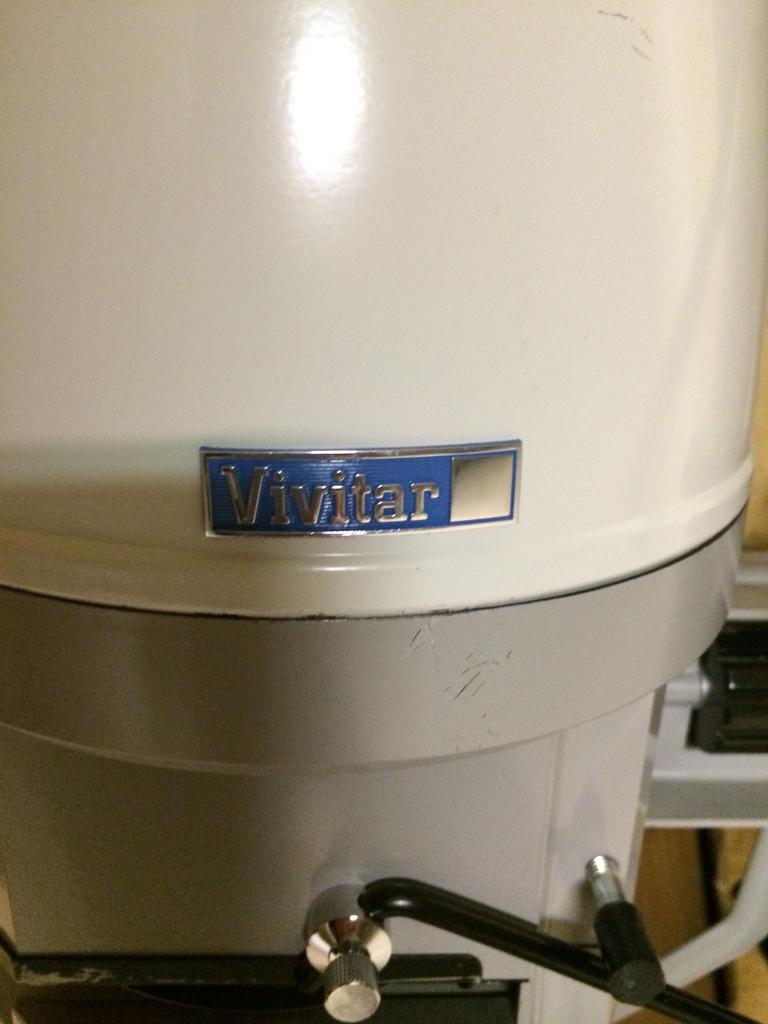What brand made this machine?
Offer a terse response. Vivitar. 